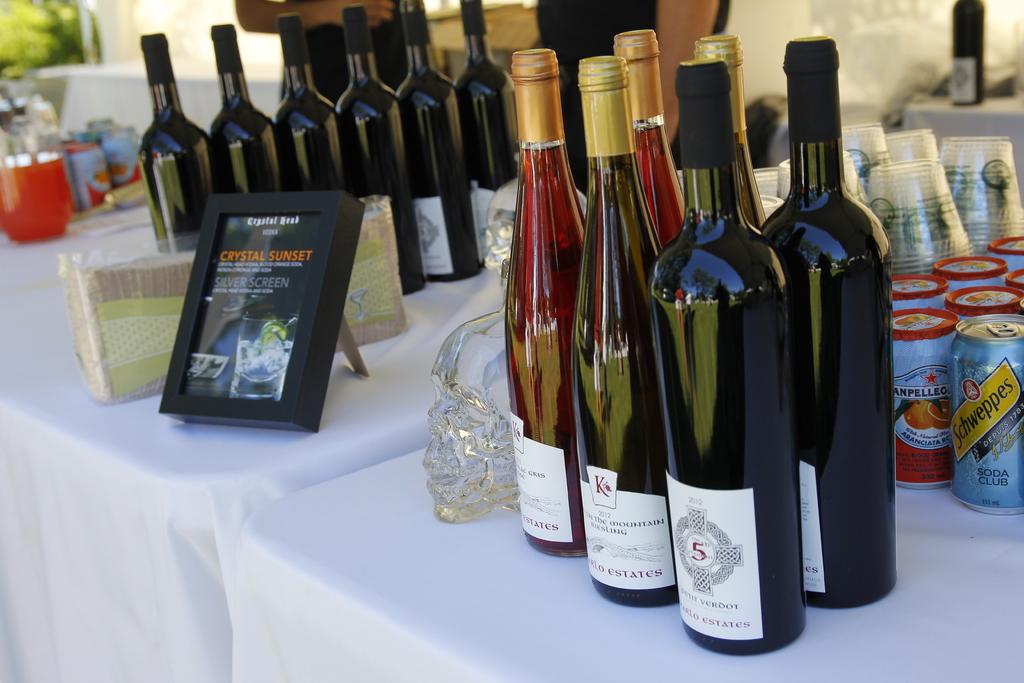What beverage is in the can?
Your response must be concise. Schweppes. 